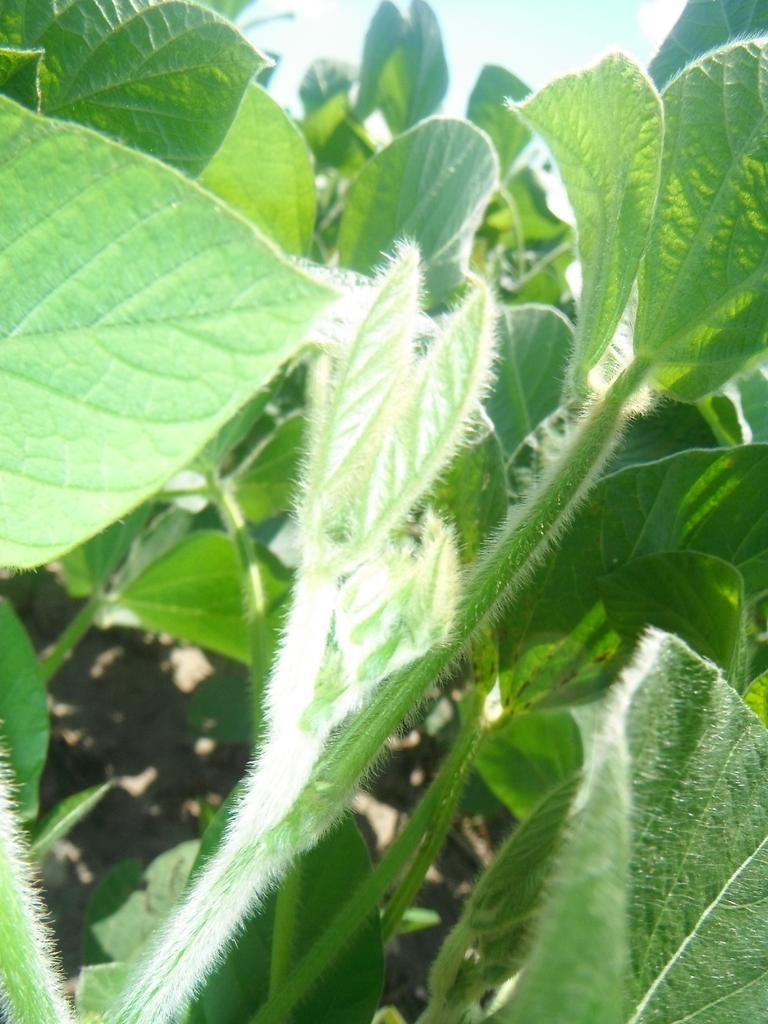Describe this image in one or two sentences. This image is taken outdoors. In this image there are few plants with green leaves and stems on the ground. At the top of the image there is the sky with clouds. 